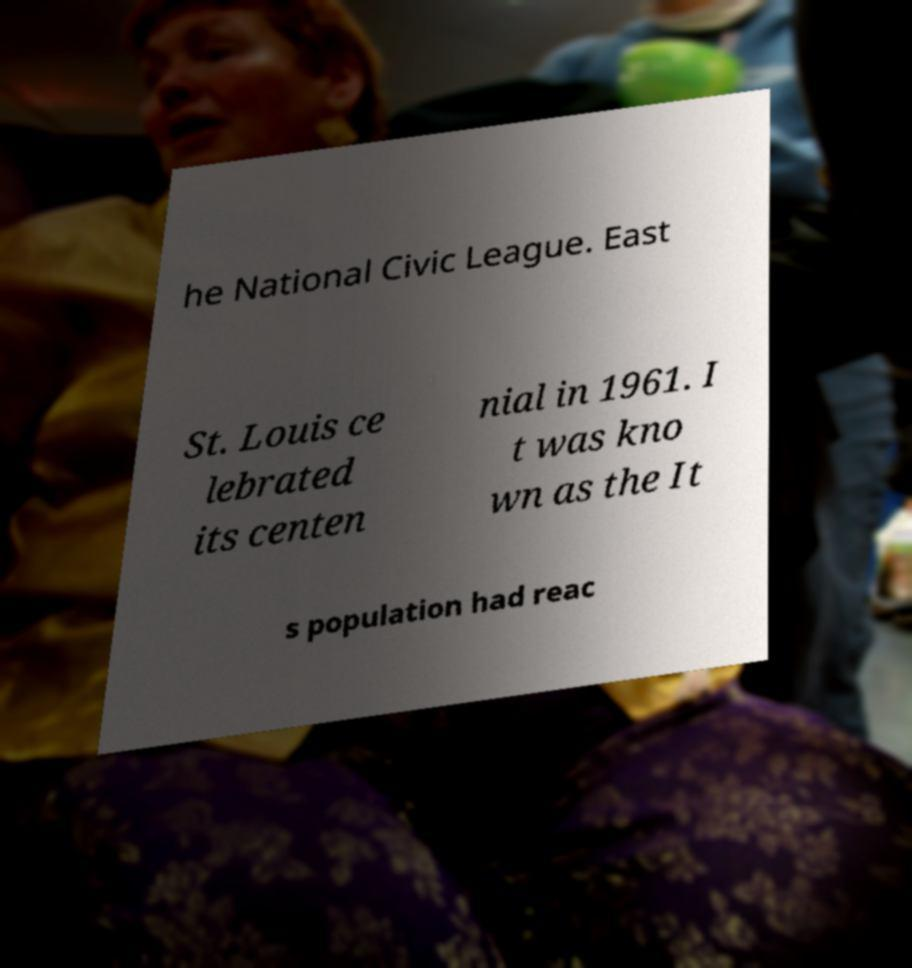What messages or text are displayed in this image? I need them in a readable, typed format. he National Civic League. East St. Louis ce lebrated its centen nial in 1961. I t was kno wn as the It s population had reac 